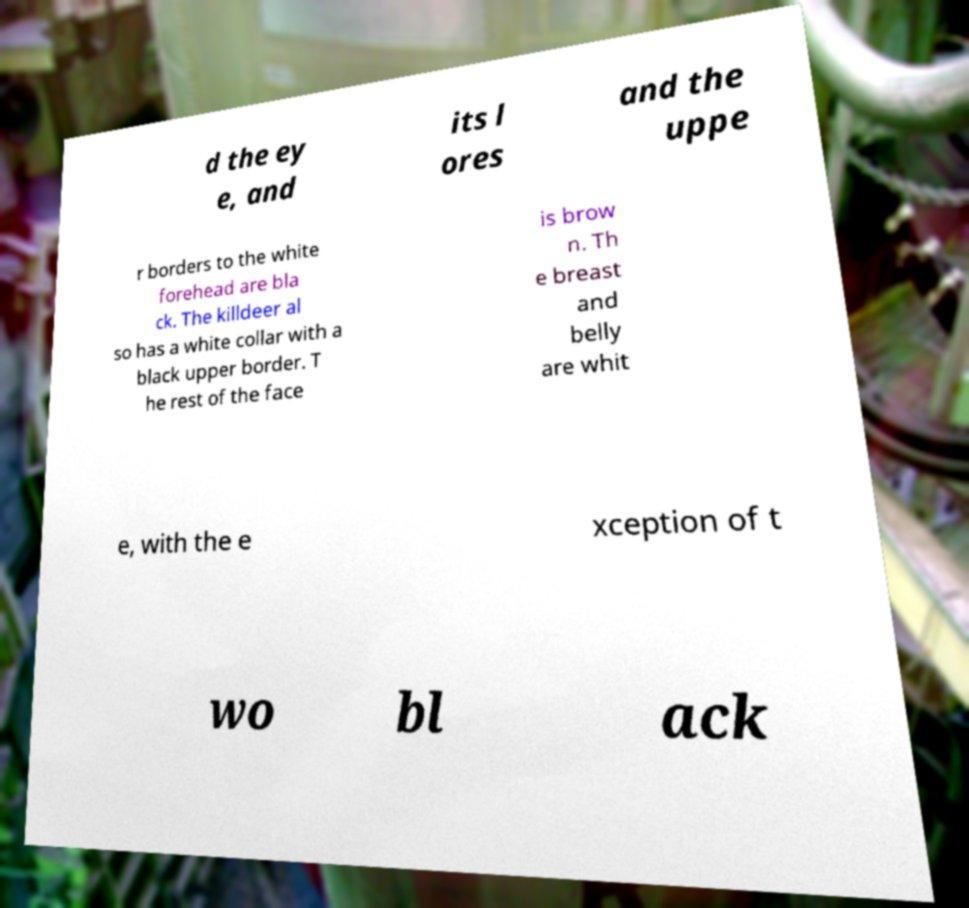Please identify and transcribe the text found in this image. d the ey e, and its l ores and the uppe r borders to the white forehead are bla ck. The killdeer al so has a white collar with a black upper border. T he rest of the face is brow n. Th e breast and belly are whit e, with the e xception of t wo bl ack 